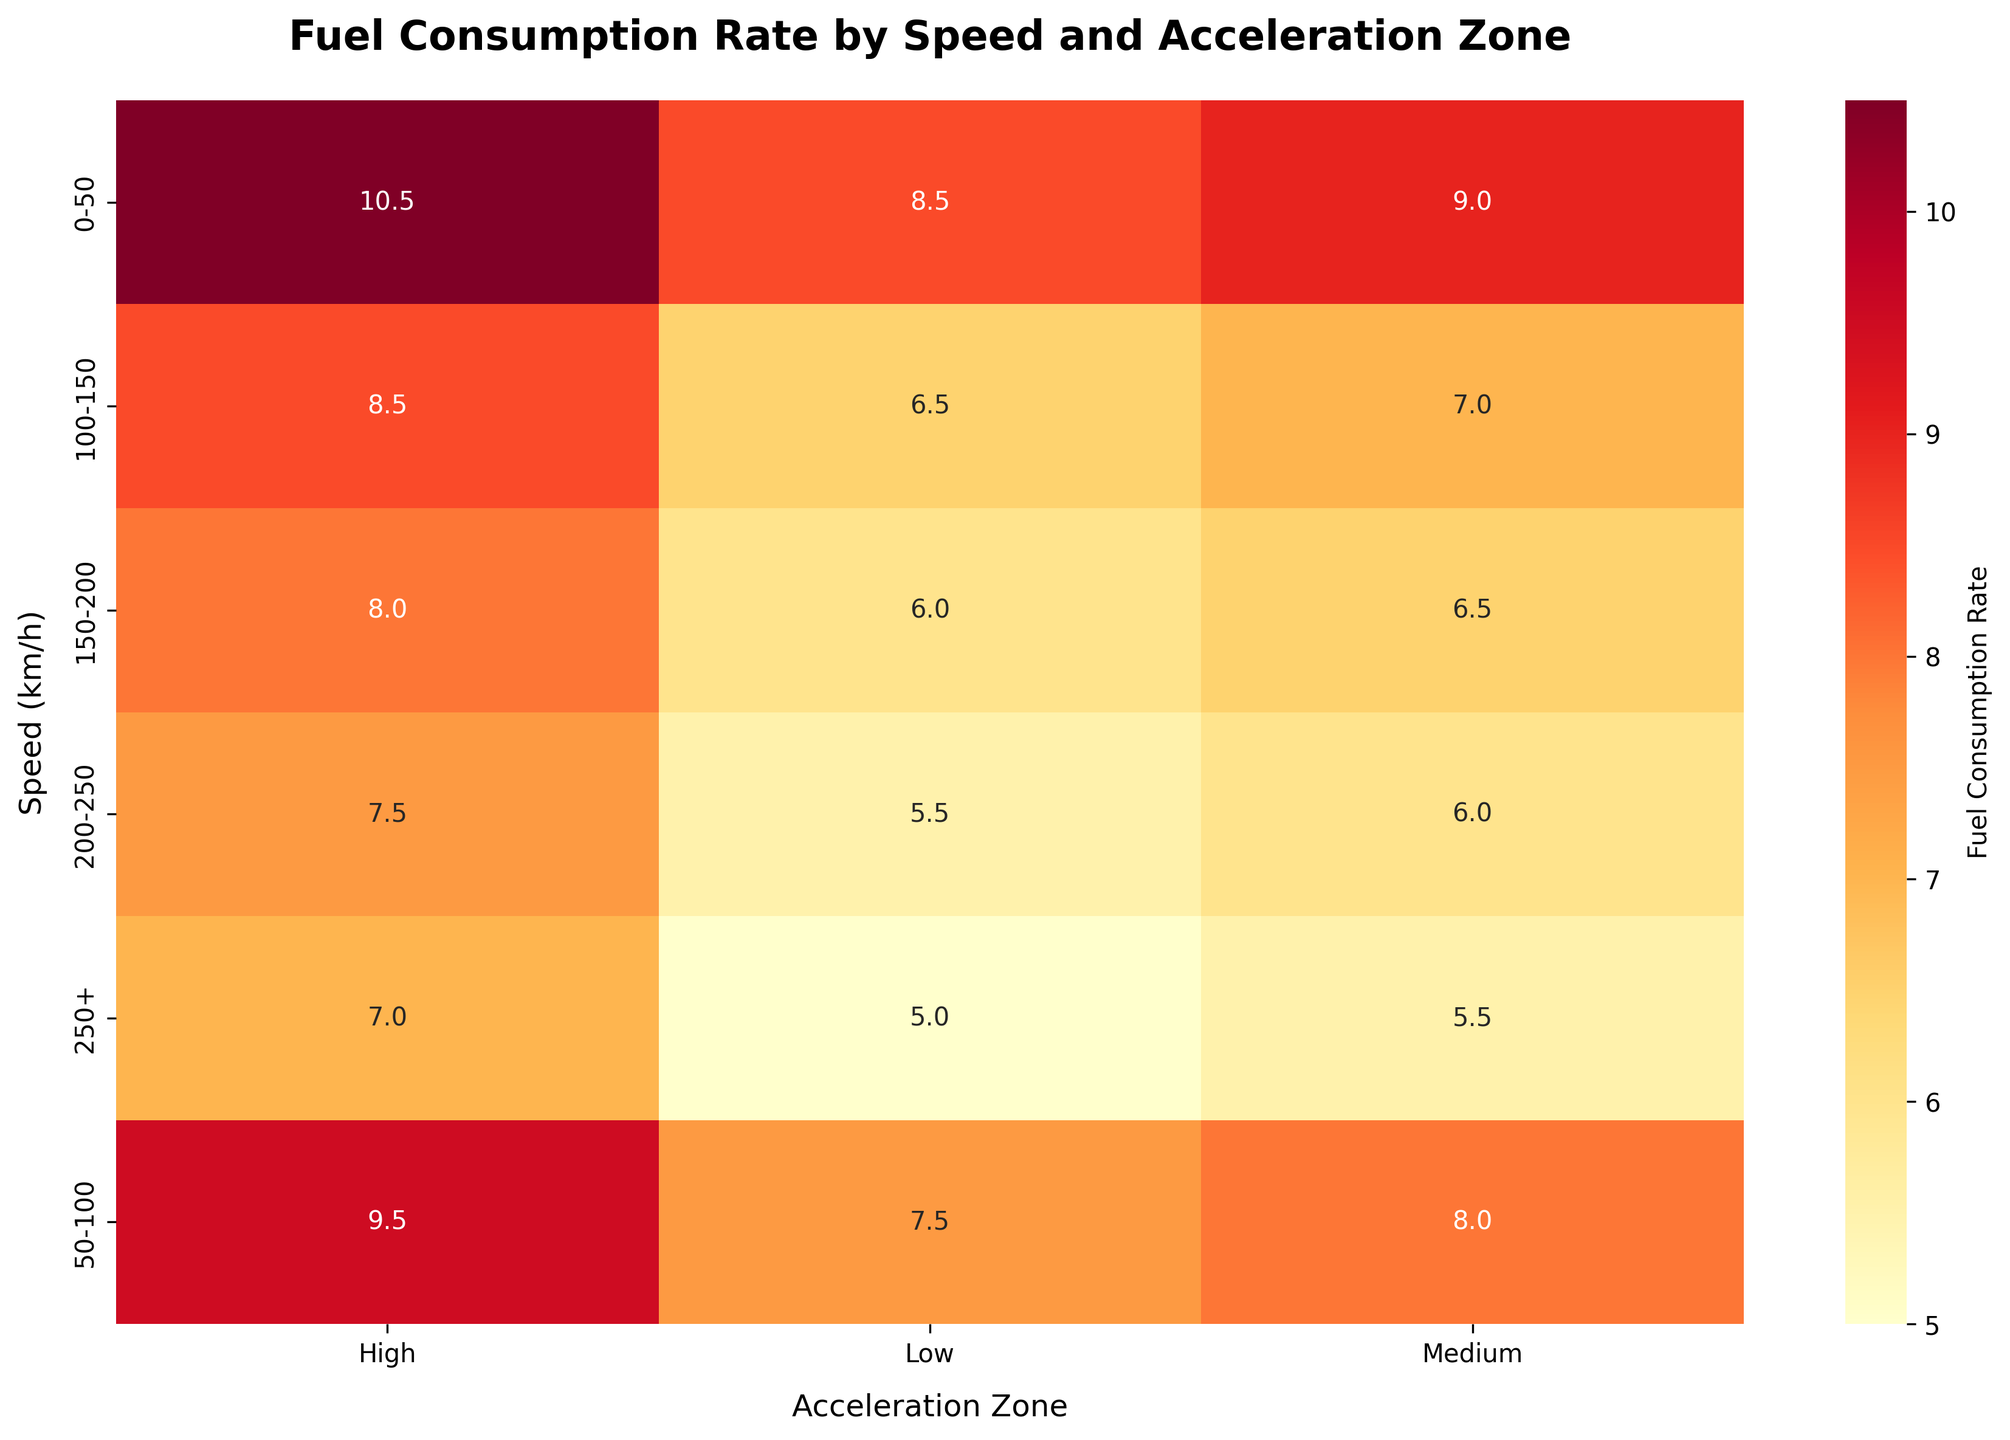what is the title of the figure? The title of the figure is found at the top of the heatmap and provides a summary of the data being visualized. Look at the top of the heatmap to find the text indicating the title.
Answer: Fuel Consumption Rate by Speed and Acceleration Zone Which speed range has the highest fuel consumption rate under the Low acceleration zone? To answer this, locate the column for "Low" acceleration zone in the heatmap and identify the cell with the highest value in this column.
Answer: 0-50 What is the fuel consumption rate for the speed range of 100-150 under the Medium acceleration zone? Find the row corresponding to the speed range "100-150" and the column corresponding to "Medium" acceleration. The value at the intersection is the fuel consumption rate you're looking for.
Answer: 7.0 Compare the fuel consumption rates between the Medium and High acceleration zones for the speed range 150-200. Which is higher? Identify the cells for "Medium" and "High" acceleration zones at the "150-200" speed range. Compare the values from these two cells.
Answer: High What is the average fuel consumption rate for all speed ranges under the Low acceleration zone? To find the average, locate all the cells under the "Low" acceleration zone and compute the mean of these values: (8.5 + 7.5 + 6.5 + 6.0 + 5.5 + 5.0) / 6.
Answer: 6.5 Is there a trend in fuel consumption rates as speed increases under the High acceleration zone? Observe the values in the "High" acceleration column from top to bottom. Determine whether the numbers are generally increasing, decreasing, or staying constant as speed increases.
Answer: Decreases For which acceleration zone does the speed range 200-250 have the lowest fuel consumption rate? Identify the row for "200-250" and compare the values across all acceleration zones (Low, Medium, High). The column with the smallest value holds your answer.
Answer: Low What is the sum of fuel consumption rates for the speed range 0-50 across all acceleration zones? Locate all the cells in the row corresponding to "0-50". Add their values: 8.5 + 9.0 + 10.5.
Answer: 28.0 How much is the difference in fuel consumption rates between the speed ranges 50-100 and 150-200 under Medium acceleration zone? Locate the values for the "50-100" and "150-200" speed ranges under the "Medium" acceleration zone. Subtract the value of 150-200 from the value of 50-100 (8.0 - 6.5).
Answer: 1.5 